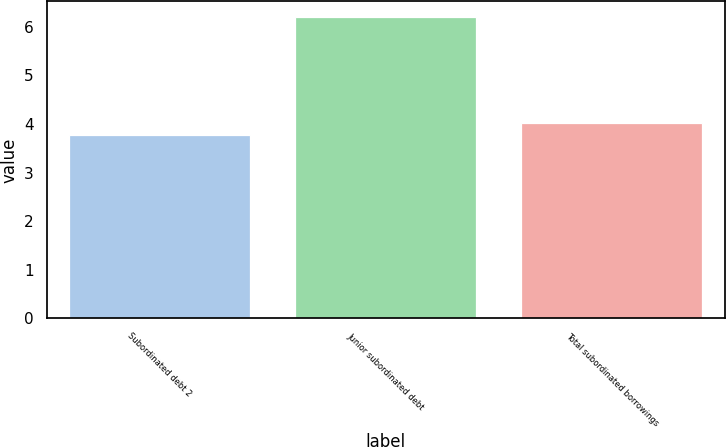Convert chart. <chart><loc_0><loc_0><loc_500><loc_500><bar_chart><fcel>Subordinated debt 2<fcel>Junior subordinated debt<fcel>Total subordinated borrowings<nl><fcel>3.77<fcel>6.21<fcel>4.02<nl></chart> 